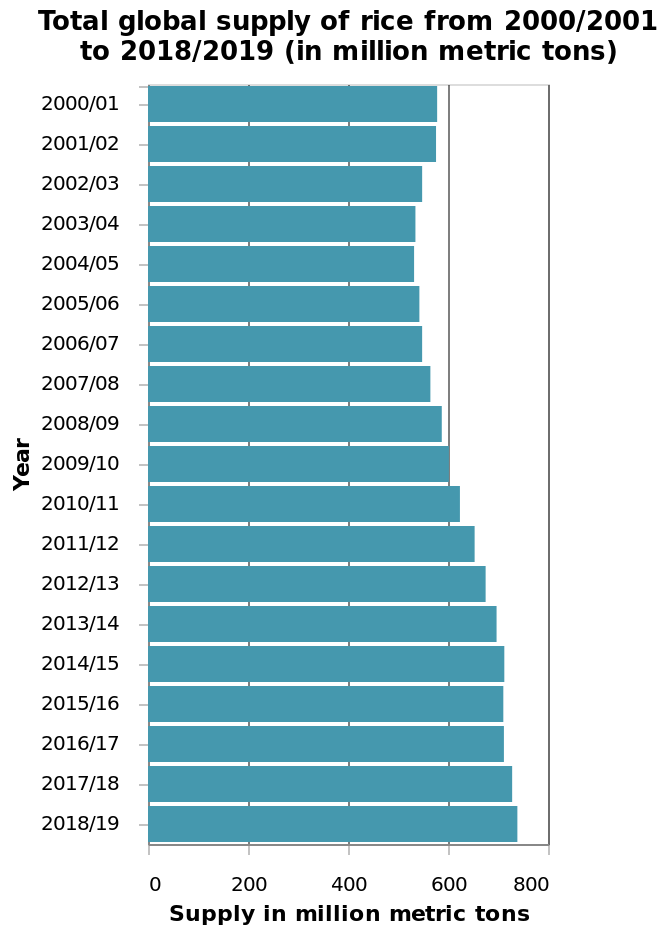<image>
Can you provide a specific instance when global rice production was particularly slow? Yes, the specific instance when global rice production was notably slow was in 2004/05. Offer a thorough analysis of the image. The slowest production of global rice was in 2004/05. 